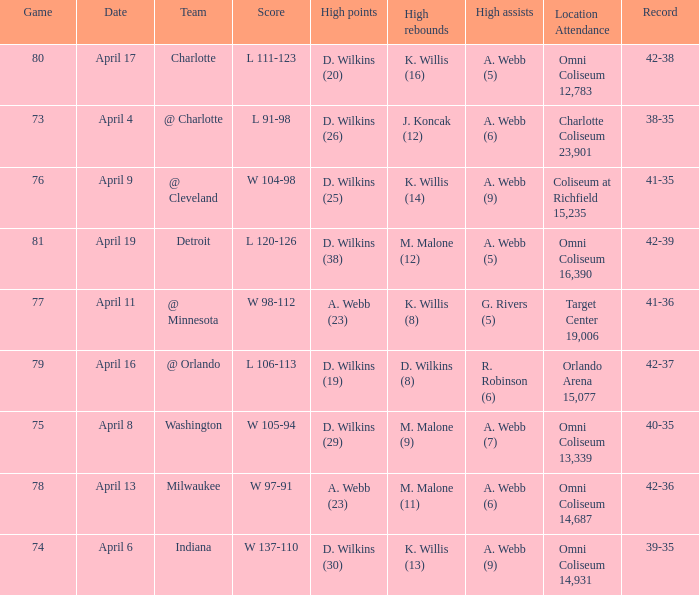Where was the location and attendance when they played milwaukee? Omni Coliseum 14,687. 